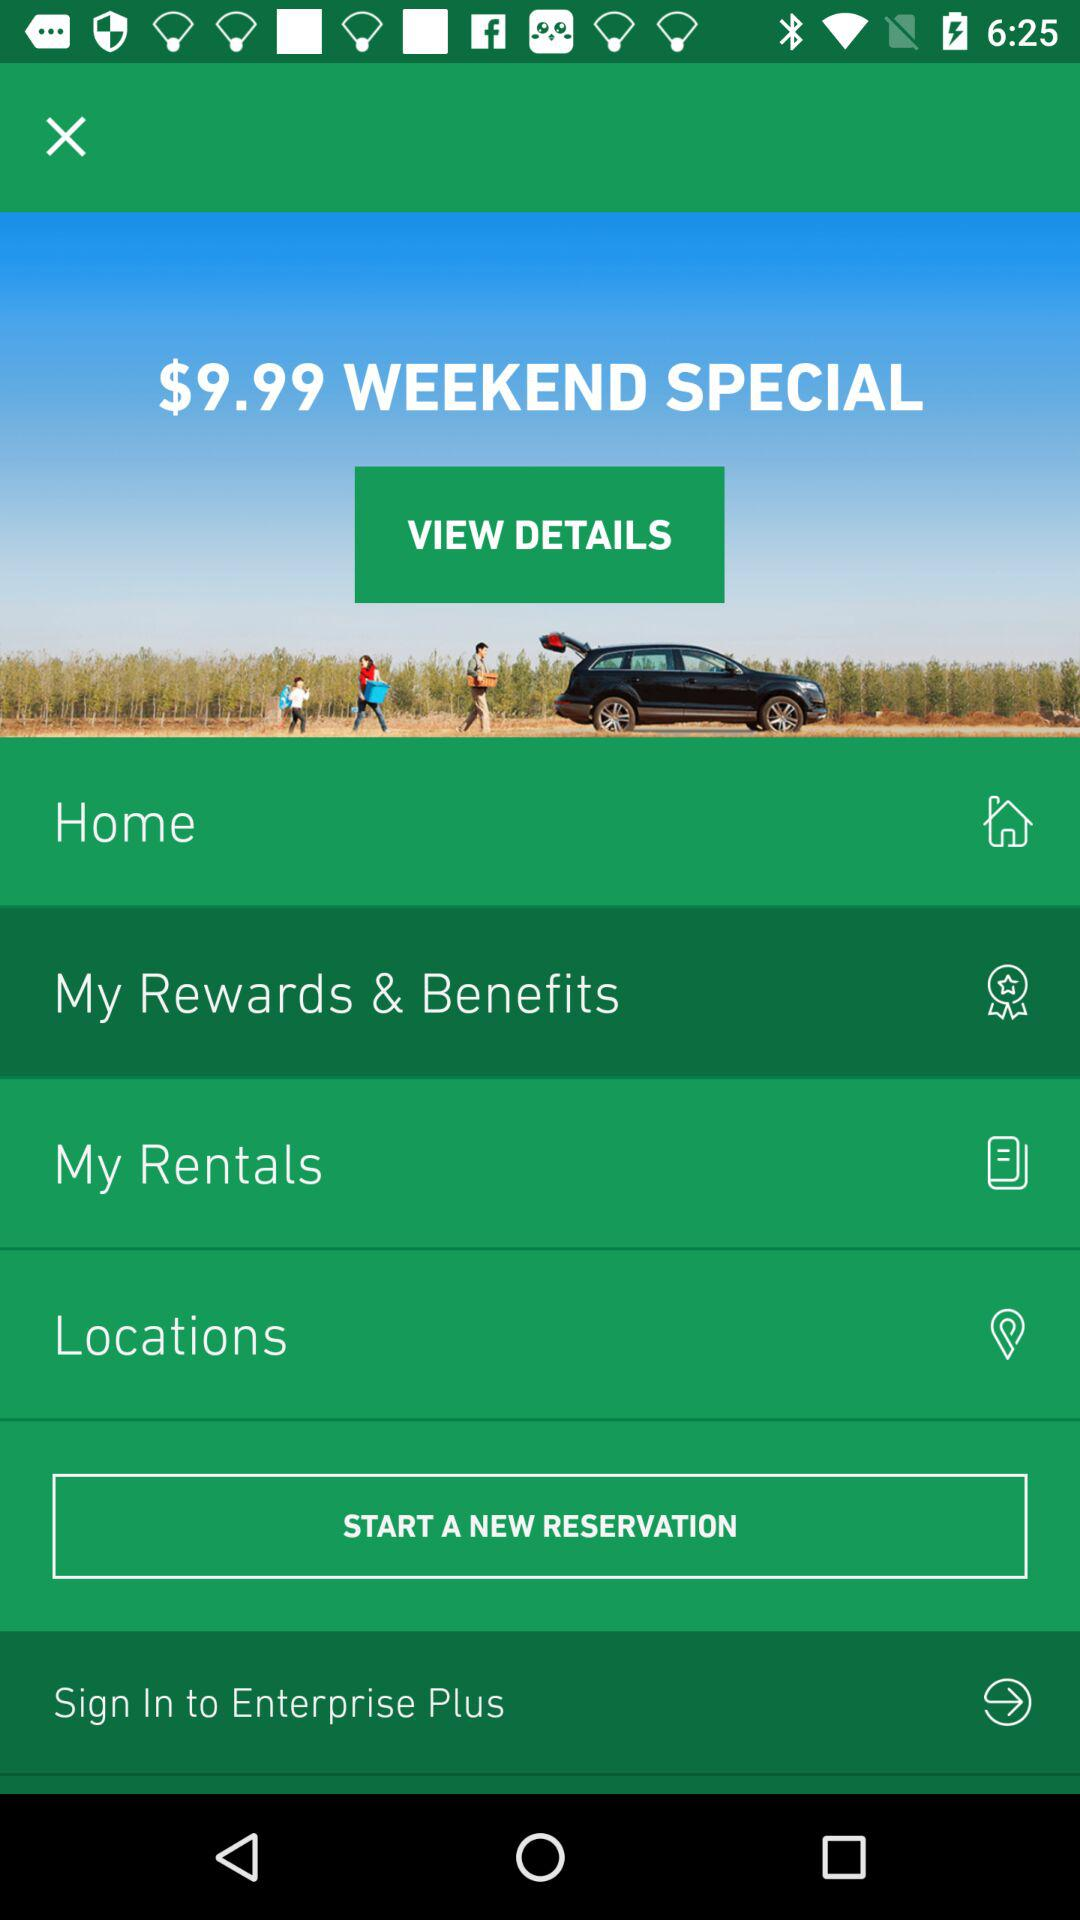Which option is selected? The selected option is "My Rewards & Benefits". 